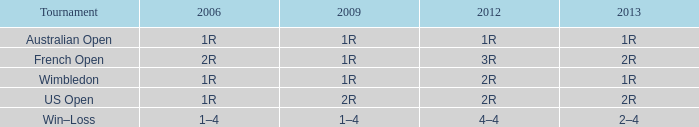In a tournament where 2013 is represented by 2r, and 2006 by 1r, what is the name of this tournament? US Open. 